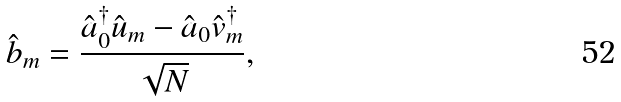<formula> <loc_0><loc_0><loc_500><loc_500>\hat { b } _ { m } = \frac { \hat { a } _ { 0 } ^ { \dagger } \hat { u } _ { m } - \hat { a } _ { 0 } \hat { v } _ { m } ^ { \dagger } } { \sqrt { N } } ,</formula> 